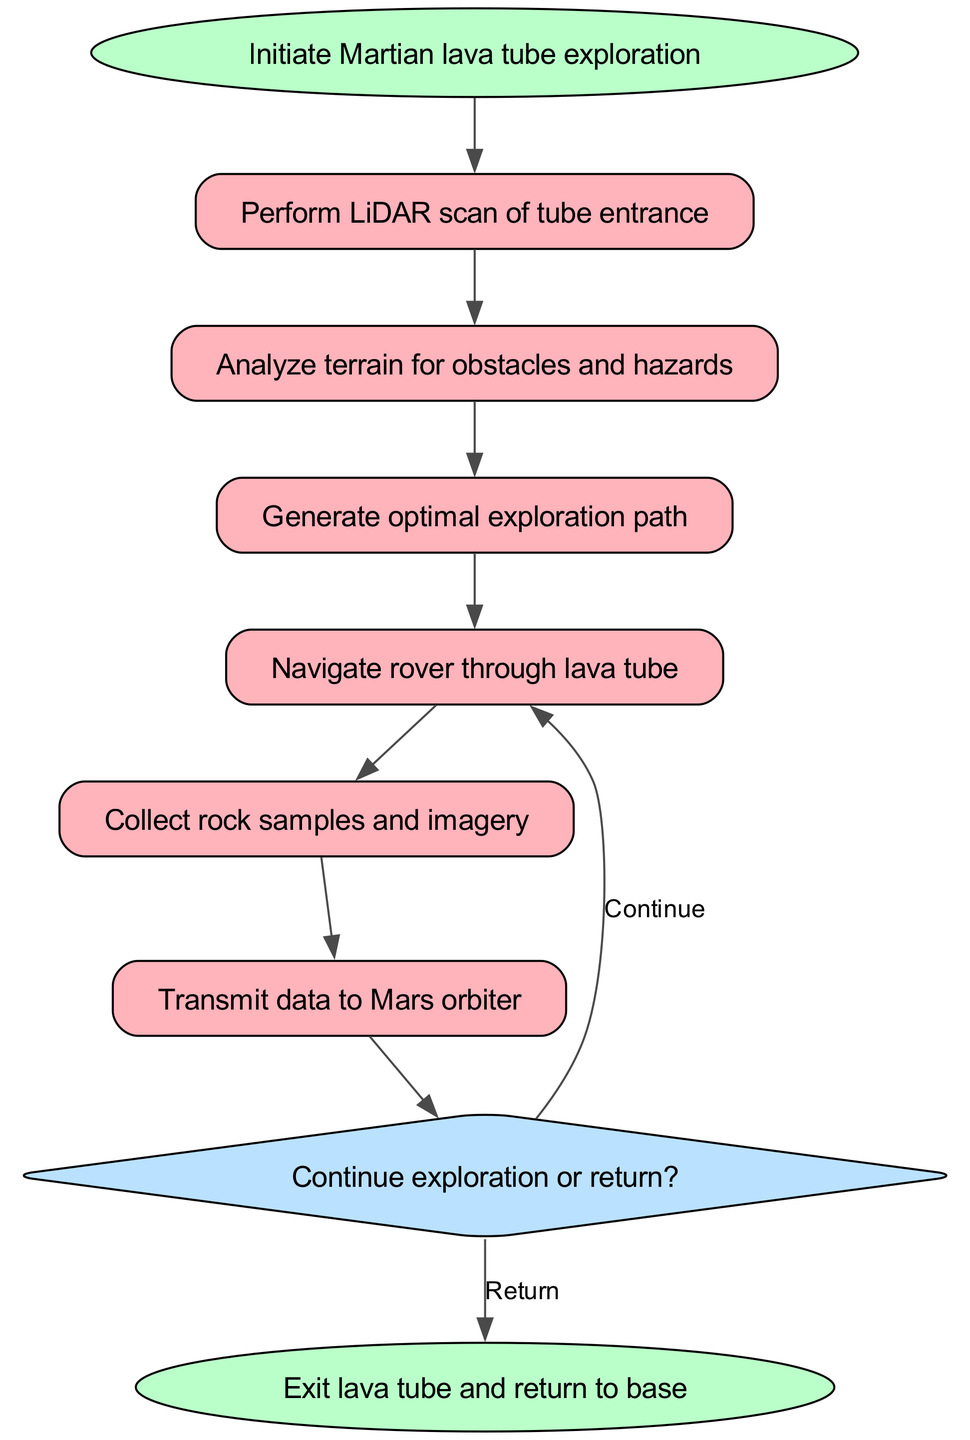What is the starting node of the flowchart? The starting node is clearly labeled in the diagram as "Initiate Martian lava tube exploration," which indicates the first action in the process.
Answer: Initiate Martian lava tube exploration How many nodes are in the flowchart? By counting all the unique labeled nodes in the diagram, there are eight nodes: start, scan, analyze, plan, move, collect, transmit, and decision, and end.
Answer: Eight What action follows the analysis of terrain? The node directly connected to the "analyze" node is "plan," which indicates the next action taken after analyzing the terrain and identifying obstacles and hazards.
Answer: Generate optimal exploration path What decision is made after data transmission? The flowchart specifies a decision node that leads either to continuing the exploration or returning, indicating that this is the critical choice made after all data is transmitted to the Mars orbiter.
Answer: Continue exploration or return What is the shape of the decision node? The node labeled "decision" is represented as a diamond shape, which visually distinguishes it from other types of nodes like ovals and rectangles, thus indicating that it requires a choice to be made.
Answer: Diamond If the decision is to return, what is the next action? The flowchart indicates that if the decision is to return, the next action is to "exit lava tube and return to base," which is clearly outlined as a connected endpoint in the diagram.
Answer: Exit lava tube and return to base What is the last action after collecting samples? The source node after "collect" leads to "transmit," indicating that the final step following the collection of samples and imagery is to send this data for analysis.
Answer: Transmit data to Mars orbiter Which node precedes the path generation? Following the flow of the diagram, it's clear that after analyzing the terrain for obstacles, the rover generates an optimal exploration path, so the node preceding "plan" is "analyze."
Answer: Analyze terrain for obstacles and hazards What will happen if the rover continues exploration? If the decision is made to continue exploration, the flowchart indicates a loop back to the "move" node, making it clear that the rover will keep navigating through the lava tube.
Answer: Navigate rover through lava tube 